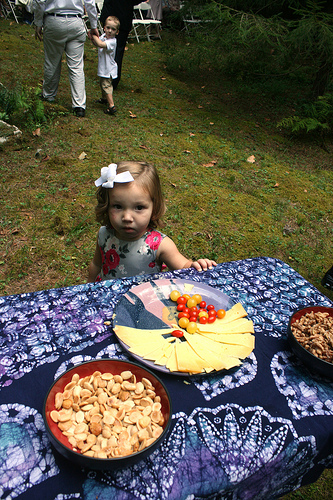<image>
Can you confirm if the baby is above the food? No. The baby is not positioned above the food. The vertical arrangement shows a different relationship. 